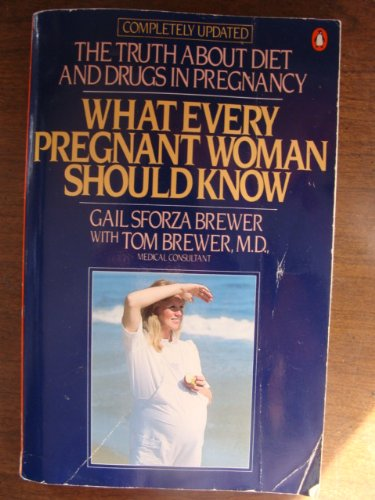Is this book still relevant for today's pregnant women? While effective at its time of printing, readers should consult more recent publications or medical advice, as research and guidelines in nutrition and pregnancy care continue to evolve. 